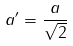Convert formula to latex. <formula><loc_0><loc_0><loc_500><loc_500>a ^ { \prime } = \frac { a } { \sqrt { 2 } }</formula> 